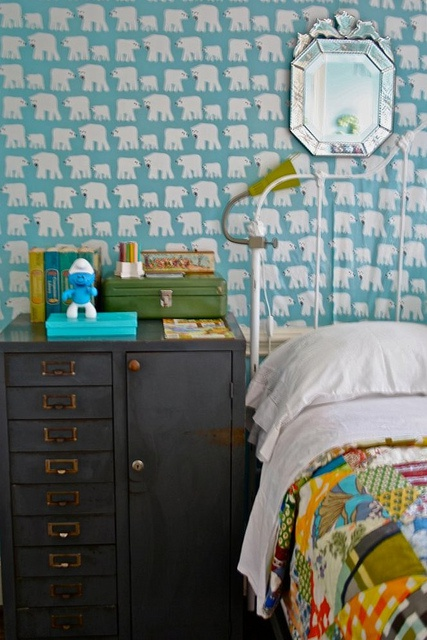Describe the objects in this image and their specific colors. I can see bed in teal, darkgray, lightgray, olive, and gray tones, book in teal and turquoise tones, teddy bear in teal, lightblue, and lightgray tones, book in teal, darkgray, tan, and olive tones, and book in teal, olive, and tan tones in this image. 